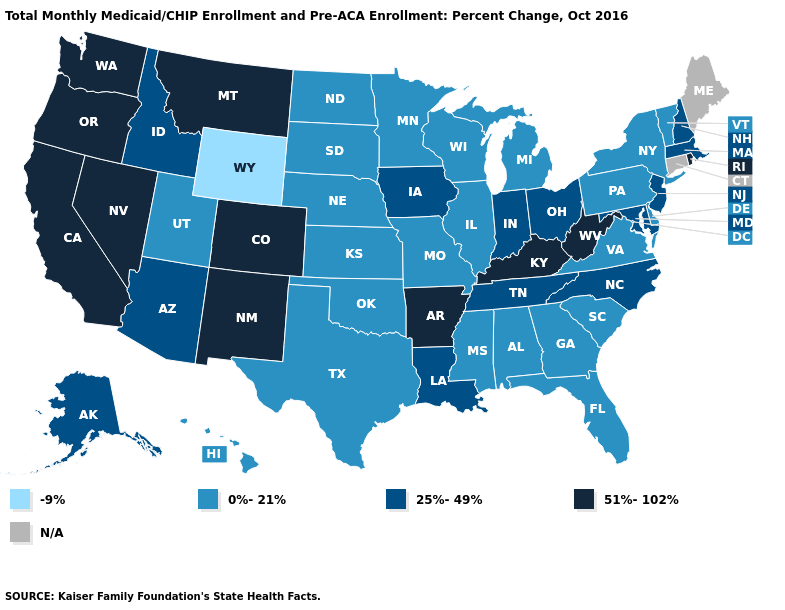Which states have the lowest value in the Northeast?
Quick response, please. New York, Pennsylvania, Vermont. Does the first symbol in the legend represent the smallest category?
Short answer required. Yes. What is the value of Iowa?
Answer briefly. 25%-49%. What is the value of West Virginia?
Answer briefly. 51%-102%. Does the first symbol in the legend represent the smallest category?
Keep it brief. Yes. Name the states that have a value in the range 51%-102%?
Short answer required. Arkansas, California, Colorado, Kentucky, Montana, Nevada, New Mexico, Oregon, Rhode Island, Washington, West Virginia. Name the states that have a value in the range 51%-102%?
Keep it brief. Arkansas, California, Colorado, Kentucky, Montana, Nevada, New Mexico, Oregon, Rhode Island, Washington, West Virginia. What is the highest value in the West ?
Quick response, please. 51%-102%. Which states hav the highest value in the MidWest?
Keep it brief. Indiana, Iowa, Ohio. Name the states that have a value in the range 0%-21%?
Concise answer only. Alabama, Delaware, Florida, Georgia, Hawaii, Illinois, Kansas, Michigan, Minnesota, Mississippi, Missouri, Nebraska, New York, North Dakota, Oklahoma, Pennsylvania, South Carolina, South Dakota, Texas, Utah, Vermont, Virginia, Wisconsin. Which states hav the highest value in the Northeast?
Short answer required. Rhode Island. What is the highest value in the West ?
Give a very brief answer. 51%-102%. What is the lowest value in the Northeast?
Answer briefly. 0%-21%. Does the first symbol in the legend represent the smallest category?
Answer briefly. Yes. 